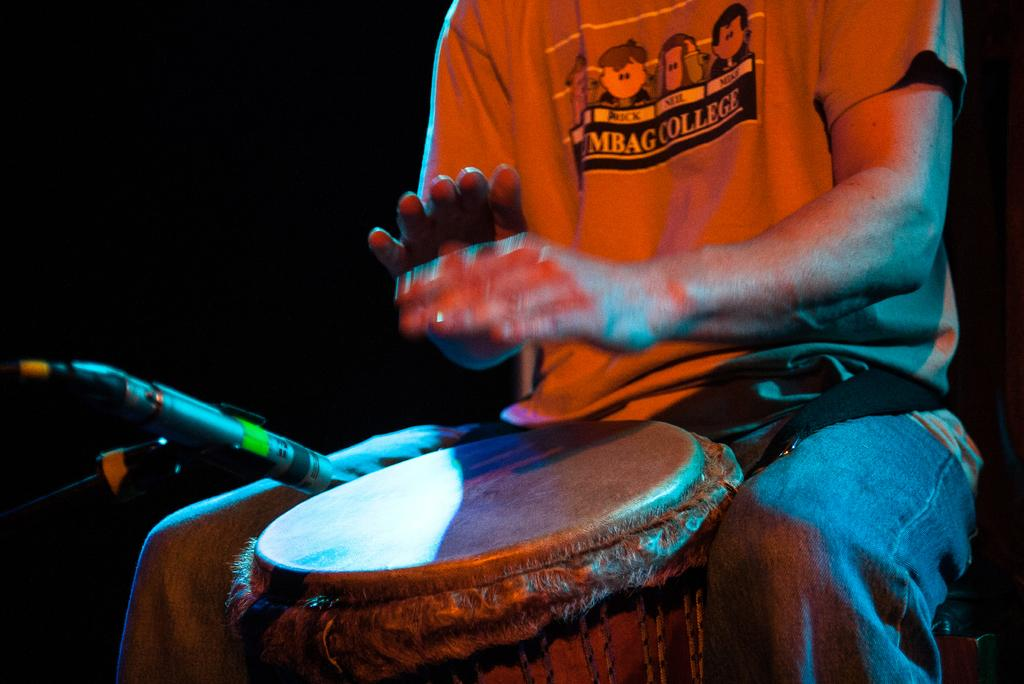What is the man in the image doing? The man is playing drums. What is the man wearing in the image? The man is wearing an orange t-shirt and blue jeans. What is in front of the man in the image? There is a microphone and a microphone stand in front of the man. What can be observed about the background of the image? The background of the image is dark. Is the man teaching a class in the image? No, the man is not teaching a class in the image; he is playing drums. Can you see any flames in the image? No, there are no flames present in the image. 